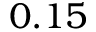Convert formula to latex. <formula><loc_0><loc_0><loc_500><loc_500>0 . 1 5</formula> 